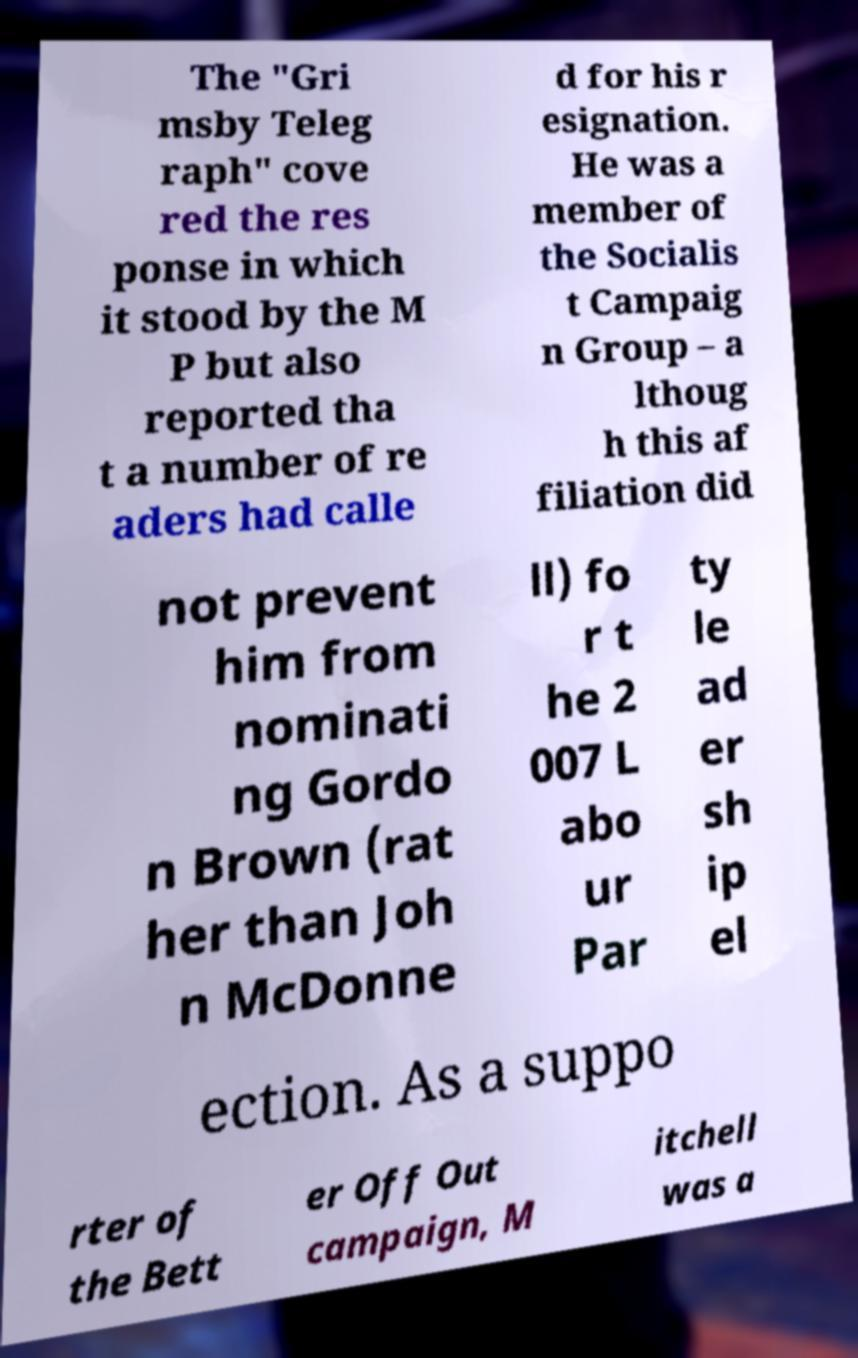Can you read and provide the text displayed in the image?This photo seems to have some interesting text. Can you extract and type it out for me? The "Gri msby Teleg raph" cove red the res ponse in which it stood by the M P but also reported tha t a number of re aders had calle d for his r esignation. He was a member of the Socialis t Campaig n Group – a lthoug h this af filiation did not prevent him from nominati ng Gordo n Brown (rat her than Joh n McDonne ll) fo r t he 2 007 L abo ur Par ty le ad er sh ip el ection. As a suppo rter of the Bett er Off Out campaign, M itchell was a 